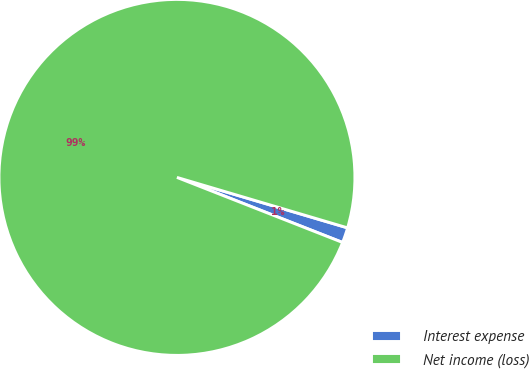<chart> <loc_0><loc_0><loc_500><loc_500><pie_chart><fcel>Interest expense<fcel>Net income (loss)<nl><fcel>1.38%<fcel>98.62%<nl></chart> 